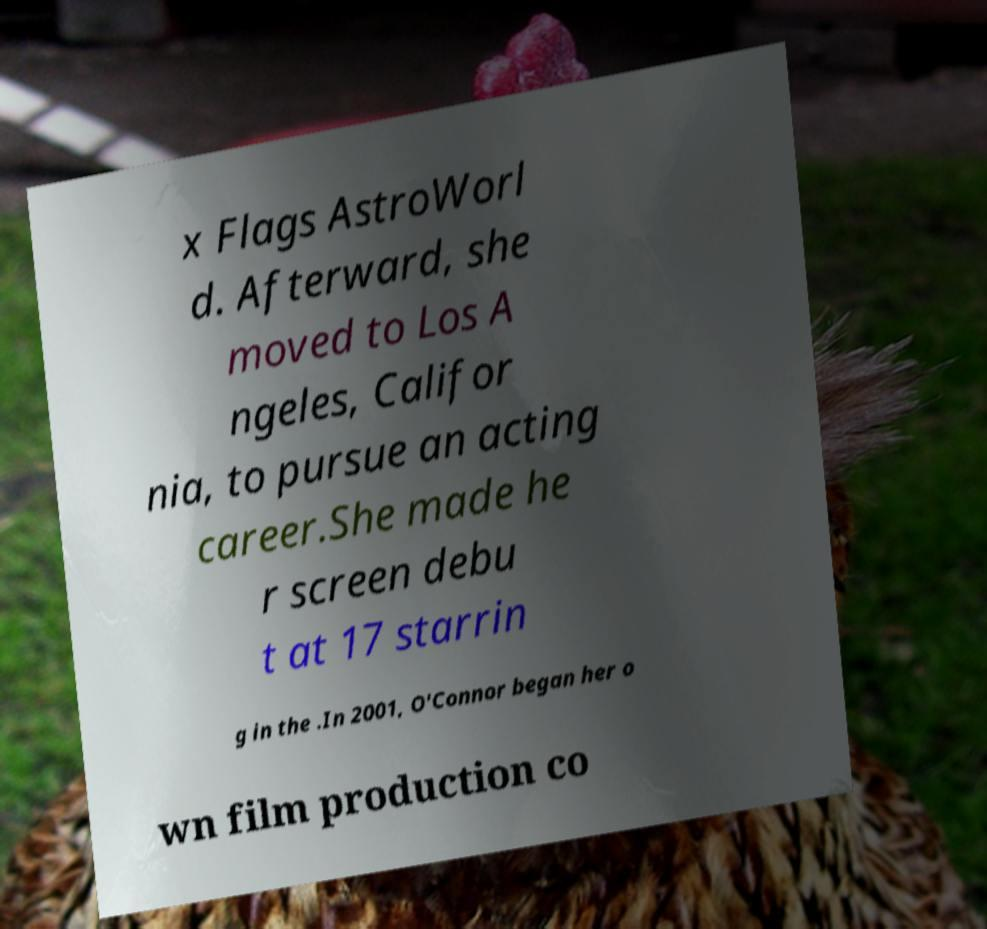Please identify and transcribe the text found in this image. x Flags AstroWorl d. Afterward, she moved to Los A ngeles, Califor nia, to pursue an acting career.She made he r screen debu t at 17 starrin g in the .In 2001, O'Connor began her o wn film production co 